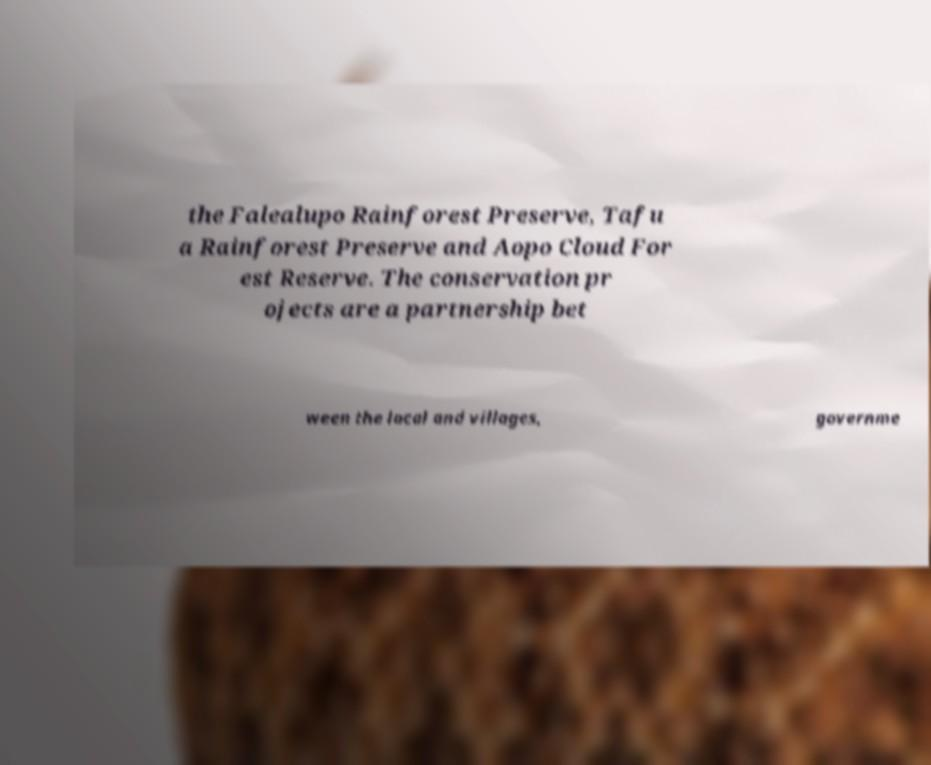Could you assist in decoding the text presented in this image and type it out clearly? the Falealupo Rainforest Preserve, Tafu a Rainforest Preserve and Aopo Cloud For est Reserve. The conservation pr ojects are a partnership bet ween the local and villages, governme 